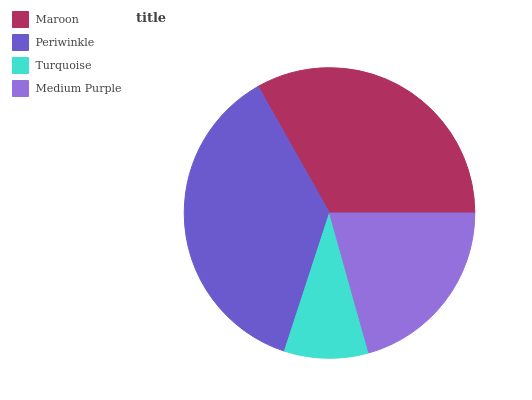Is Turquoise the minimum?
Answer yes or no. Yes. Is Periwinkle the maximum?
Answer yes or no. Yes. Is Periwinkle the minimum?
Answer yes or no. No. Is Turquoise the maximum?
Answer yes or no. No. Is Periwinkle greater than Turquoise?
Answer yes or no. Yes. Is Turquoise less than Periwinkle?
Answer yes or no. Yes. Is Turquoise greater than Periwinkle?
Answer yes or no. No. Is Periwinkle less than Turquoise?
Answer yes or no. No. Is Maroon the high median?
Answer yes or no. Yes. Is Medium Purple the low median?
Answer yes or no. Yes. Is Periwinkle the high median?
Answer yes or no. No. Is Turquoise the low median?
Answer yes or no. No. 